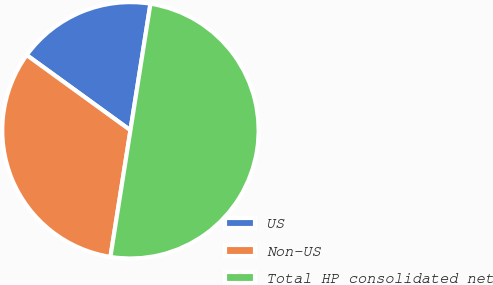Convert chart to OTSL. <chart><loc_0><loc_0><loc_500><loc_500><pie_chart><fcel>US<fcel>Non-US<fcel>Total HP consolidated net<nl><fcel>17.51%<fcel>32.49%<fcel>50.0%<nl></chart> 